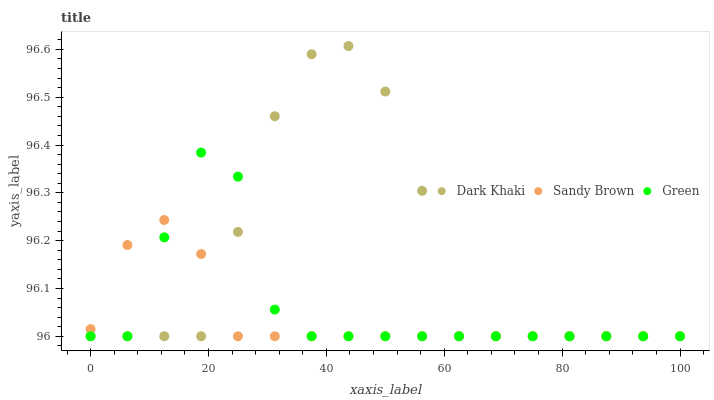Does Sandy Brown have the minimum area under the curve?
Answer yes or no. Yes. Does Dark Khaki have the maximum area under the curve?
Answer yes or no. Yes. Does Green have the minimum area under the curve?
Answer yes or no. No. Does Green have the maximum area under the curve?
Answer yes or no. No. Is Sandy Brown the smoothest?
Answer yes or no. Yes. Is Dark Khaki the roughest?
Answer yes or no. Yes. Is Green the smoothest?
Answer yes or no. No. Is Green the roughest?
Answer yes or no. No. Does Dark Khaki have the lowest value?
Answer yes or no. Yes. Does Dark Khaki have the highest value?
Answer yes or no. Yes. Does Green have the highest value?
Answer yes or no. No. Does Sandy Brown intersect Green?
Answer yes or no. Yes. Is Sandy Brown less than Green?
Answer yes or no. No. Is Sandy Brown greater than Green?
Answer yes or no. No. 